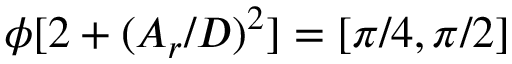<formula> <loc_0><loc_0><loc_500><loc_500>\phi [ 2 + ( A _ { r } / D ) ^ { 2 } ] = [ \pi / 4 , \pi / 2 ]</formula> 